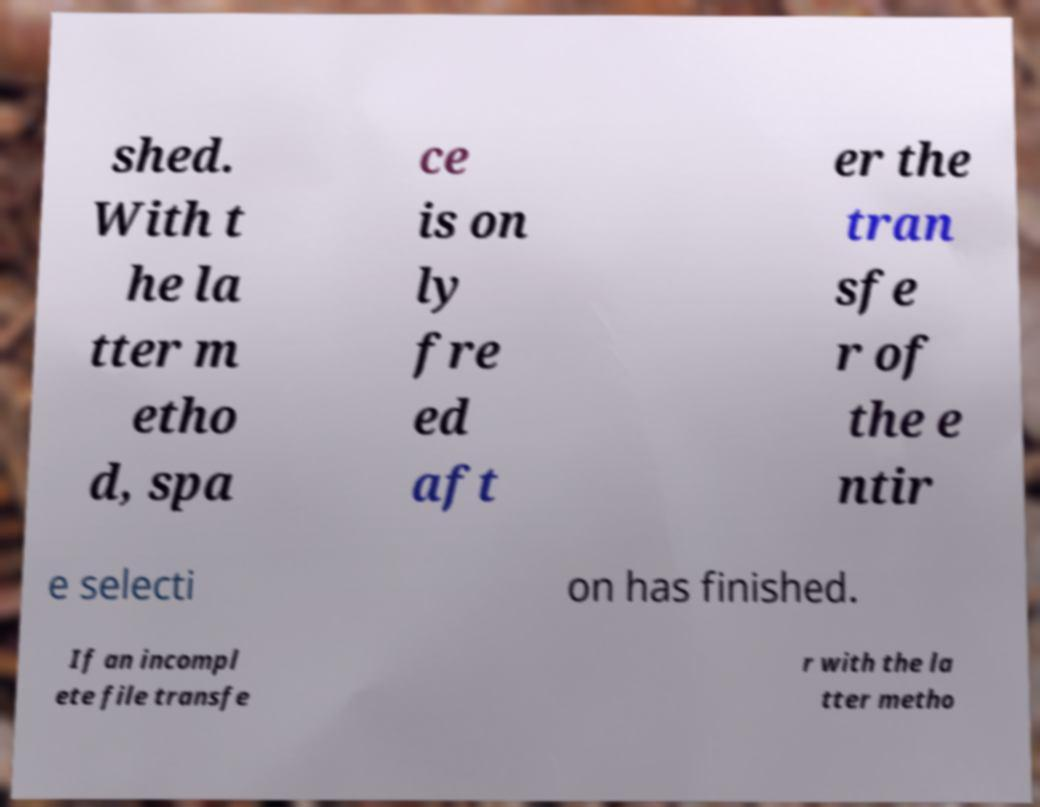Can you accurately transcribe the text from the provided image for me? shed. With t he la tter m etho d, spa ce is on ly fre ed aft er the tran sfe r of the e ntir e selecti on has finished. If an incompl ete file transfe r with the la tter metho 